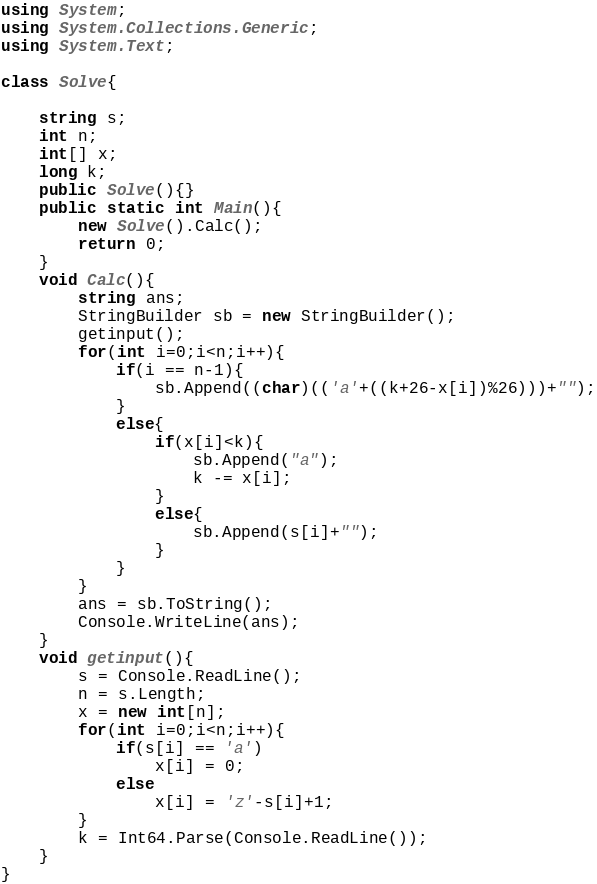Convert code to text. <code><loc_0><loc_0><loc_500><loc_500><_C#_>using System;
using System.Collections.Generic;
using System.Text;

class Solve{
    
    string s;
    int n;
    int[] x;
    long k;
    public Solve(){}
    public static int Main(){
        new Solve().Calc();
        return 0;
    }
    void Calc(){
        string ans;
        StringBuilder sb = new StringBuilder();
        getinput();
        for(int i=0;i<n;i++){
            if(i == n-1){
                sb.Append((char)(('a'+((k+26-x[i])%26)))+"");
            }
            else{
                if(x[i]<k){
                    sb.Append("a");
                    k -= x[i];
                }
                else{
                    sb.Append(s[i]+"");
                }
            }
        }
        ans = sb.ToString();
        Console.WriteLine(ans);
    }
    void getinput(){
        s = Console.ReadLine();
        n = s.Length;
        x = new int[n];
        for(int i=0;i<n;i++){
            if(s[i] == 'a')
                x[i] = 0;
            else
                x[i] = 'z'-s[i]+1;
        }
        k = Int64.Parse(Console.ReadLine());
    }    
}</code> 